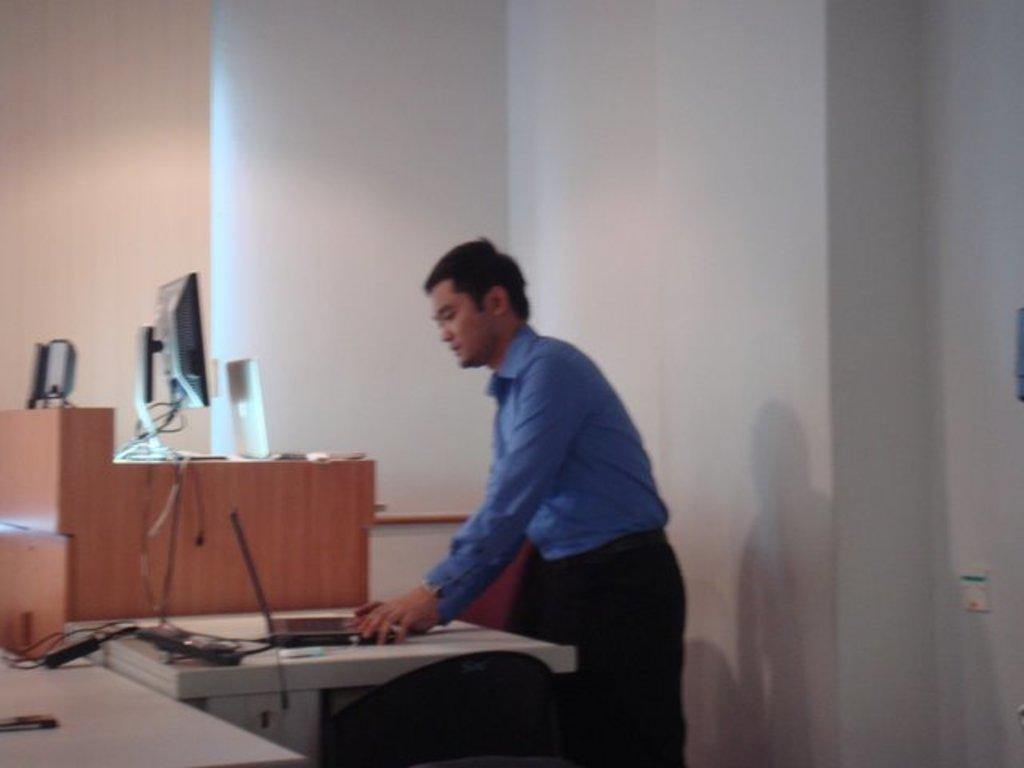What type of electronic devices can be seen in the image? There are laptops and a monitor in the image. What might be used to connect the devices in the image? Cables are present in the image for connecting the devices. What is on the tables in the image? There are objects on the tables, which may include the laptops, monitor, and cables. Can you describe the person in the image? A person is standing in the image, but their appearance or actions are not specified. What is visible in the background of the image? There is a wall in the background of the image. What type of cushion is being used to lift the laptop in the image? There is no cushion or lifting action involving a laptop in the image. 